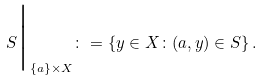Convert formula to latex. <formula><loc_0><loc_0><loc_500><loc_500>S { \Big | } _ { \{ a \} \times X } \colon = \left \{ y \in X \colon ( a , y ) \in S \right \} .</formula> 